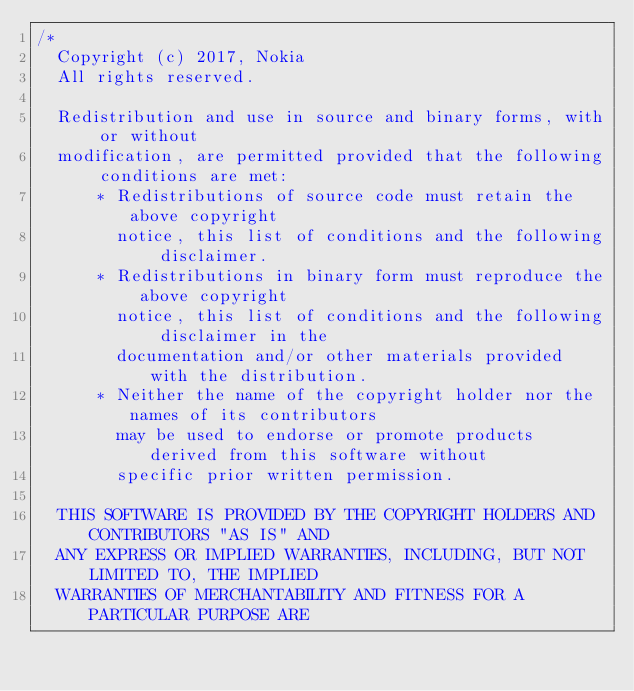Convert code to text. <code><loc_0><loc_0><loc_500><loc_500><_C#_>/*
  Copyright (c) 2017, Nokia
  All rights reserved.

  Redistribution and use in source and binary forms, with or without
  modification, are permitted provided that the following conditions are met:
      * Redistributions of source code must retain the above copyright
        notice, this list of conditions and the following disclaimer.
      * Redistributions in binary form must reproduce the above copyright
        notice, this list of conditions and the following disclaimer in the
        documentation and/or other materials provided with the distribution.
      * Neither the name of the copyright holder nor the names of its contributors
        may be used to endorse or promote products derived from this software without
        specific prior written permission.

  THIS SOFTWARE IS PROVIDED BY THE COPYRIGHT HOLDERS AND CONTRIBUTORS "AS IS" AND
  ANY EXPRESS OR IMPLIED WARRANTIES, INCLUDING, BUT NOT LIMITED TO, THE IMPLIED
  WARRANTIES OF MERCHANTABILITY AND FITNESS FOR A PARTICULAR PURPOSE ARE</code> 